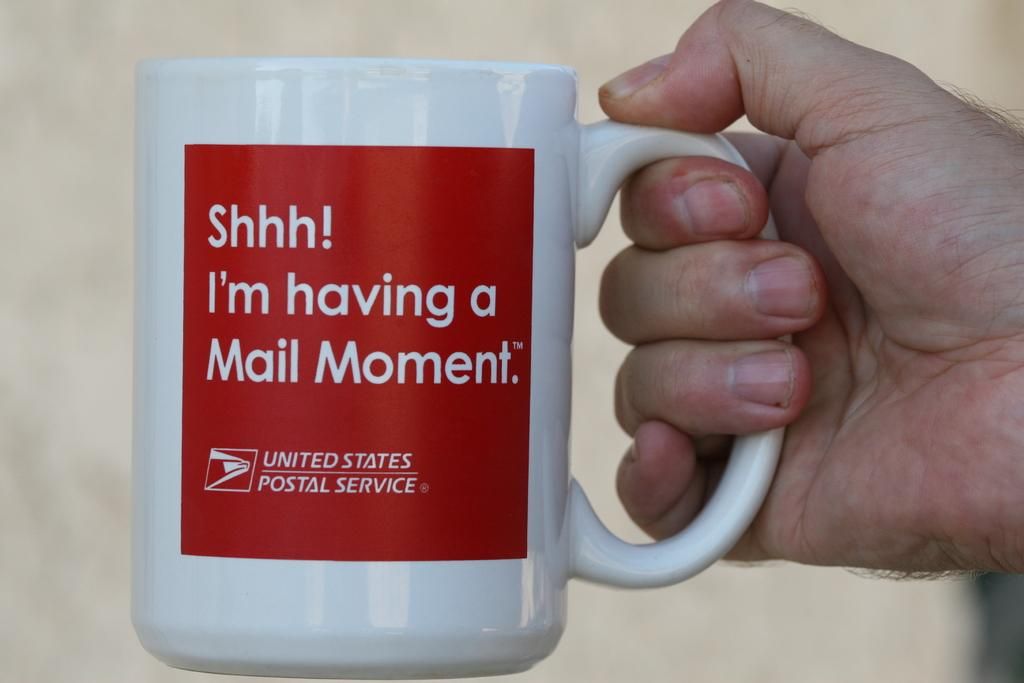<image>
Share a concise interpretation of the image provided. a white mug that has a red square that says 'shhh! i'm having a mail movement.' on it 